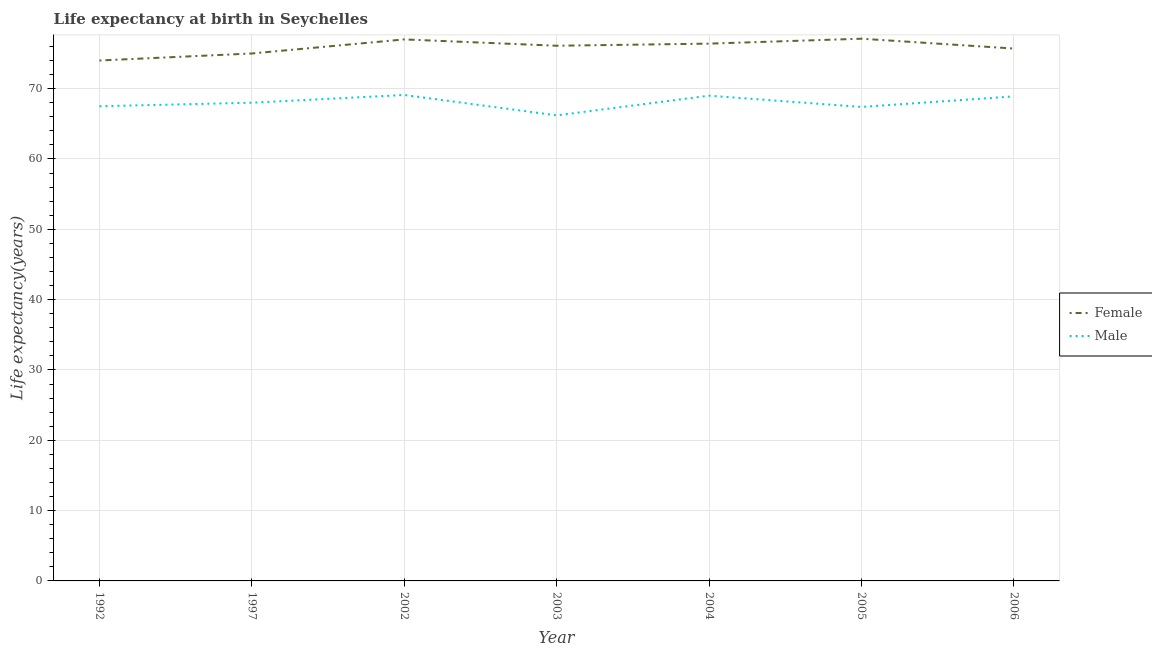Does the line corresponding to life expectancy(male) intersect with the line corresponding to life expectancy(female)?
Provide a succinct answer. No. Is the number of lines equal to the number of legend labels?
Offer a very short reply. Yes. Across all years, what is the maximum life expectancy(female)?
Give a very brief answer. 77.1. Across all years, what is the minimum life expectancy(male)?
Make the answer very short. 66.2. In which year was the life expectancy(female) maximum?
Make the answer very short. 2005. In which year was the life expectancy(male) minimum?
Your response must be concise. 2003. What is the total life expectancy(male) in the graph?
Provide a short and direct response. 476.1. What is the difference between the life expectancy(male) in 1992 and that in 2003?
Offer a very short reply. 1.3. What is the difference between the life expectancy(male) in 2003 and the life expectancy(female) in 2005?
Make the answer very short. -10.9. What is the average life expectancy(male) per year?
Your answer should be compact. 68.01. In the year 2006, what is the difference between the life expectancy(female) and life expectancy(male)?
Offer a terse response. 6.8. In how many years, is the life expectancy(female) greater than 30 years?
Keep it short and to the point. 7. What is the ratio of the life expectancy(female) in 2004 to that in 2006?
Offer a very short reply. 1.01. What is the difference between the highest and the second highest life expectancy(female)?
Make the answer very short. 0.1. What is the difference between the highest and the lowest life expectancy(female)?
Make the answer very short. 3.1. Is the sum of the life expectancy(female) in 1992 and 2005 greater than the maximum life expectancy(male) across all years?
Give a very brief answer. Yes. Is the life expectancy(female) strictly greater than the life expectancy(male) over the years?
Offer a terse response. Yes. How many lines are there?
Your answer should be compact. 2. How many years are there in the graph?
Offer a terse response. 7. What is the difference between two consecutive major ticks on the Y-axis?
Ensure brevity in your answer.  10. Does the graph contain grids?
Your response must be concise. Yes. What is the title of the graph?
Offer a very short reply. Life expectancy at birth in Seychelles. Does "Secondary education" appear as one of the legend labels in the graph?
Your answer should be very brief. No. What is the label or title of the Y-axis?
Make the answer very short. Life expectancy(years). What is the Life expectancy(years) of Female in 1992?
Offer a very short reply. 74. What is the Life expectancy(years) in Male in 1992?
Your answer should be very brief. 67.5. What is the Life expectancy(years) in Female in 1997?
Keep it short and to the point. 75. What is the Life expectancy(years) in Male in 1997?
Your answer should be very brief. 68. What is the Life expectancy(years) of Female in 2002?
Your answer should be very brief. 77. What is the Life expectancy(years) of Male in 2002?
Offer a very short reply. 69.1. What is the Life expectancy(years) of Female in 2003?
Provide a short and direct response. 76.1. What is the Life expectancy(years) of Male in 2003?
Offer a very short reply. 66.2. What is the Life expectancy(years) of Female in 2004?
Offer a terse response. 76.4. What is the Life expectancy(years) in Male in 2004?
Make the answer very short. 69. What is the Life expectancy(years) in Female in 2005?
Your answer should be very brief. 77.1. What is the Life expectancy(years) of Male in 2005?
Your answer should be very brief. 67.4. What is the Life expectancy(years) of Female in 2006?
Ensure brevity in your answer.  75.7. What is the Life expectancy(years) of Male in 2006?
Provide a succinct answer. 68.9. Across all years, what is the maximum Life expectancy(years) in Female?
Your answer should be very brief. 77.1. Across all years, what is the maximum Life expectancy(years) in Male?
Your response must be concise. 69.1. Across all years, what is the minimum Life expectancy(years) in Male?
Keep it short and to the point. 66.2. What is the total Life expectancy(years) of Female in the graph?
Offer a terse response. 531.3. What is the total Life expectancy(years) in Male in the graph?
Give a very brief answer. 476.1. What is the difference between the Life expectancy(years) in Female in 1992 and that in 2002?
Make the answer very short. -3. What is the difference between the Life expectancy(years) of Male in 1992 and that in 2003?
Ensure brevity in your answer.  1.3. What is the difference between the Life expectancy(years) of Female in 1992 and that in 2004?
Keep it short and to the point. -2.4. What is the difference between the Life expectancy(years) in Male in 1992 and that in 2004?
Make the answer very short. -1.5. What is the difference between the Life expectancy(years) of Female in 1992 and that in 2005?
Offer a terse response. -3.1. What is the difference between the Life expectancy(years) in Male in 1992 and that in 2005?
Give a very brief answer. 0.1. What is the difference between the Life expectancy(years) in Male in 1992 and that in 2006?
Your answer should be very brief. -1.4. What is the difference between the Life expectancy(years) of Female in 1997 and that in 2003?
Provide a short and direct response. -1.1. What is the difference between the Life expectancy(years) of Male in 1997 and that in 2004?
Provide a succinct answer. -1. What is the difference between the Life expectancy(years) in Female in 1997 and that in 2005?
Make the answer very short. -2.1. What is the difference between the Life expectancy(years) in Female in 1997 and that in 2006?
Give a very brief answer. -0.7. What is the difference between the Life expectancy(years) of Female in 2002 and that in 2003?
Provide a succinct answer. 0.9. What is the difference between the Life expectancy(years) of Male in 2002 and that in 2003?
Give a very brief answer. 2.9. What is the difference between the Life expectancy(years) of Female in 2002 and that in 2004?
Give a very brief answer. 0.6. What is the difference between the Life expectancy(years) in Male in 2002 and that in 2004?
Offer a terse response. 0.1. What is the difference between the Life expectancy(years) of Female in 2002 and that in 2005?
Make the answer very short. -0.1. What is the difference between the Life expectancy(years) of Male in 2002 and that in 2005?
Keep it short and to the point. 1.7. What is the difference between the Life expectancy(years) in Female in 2002 and that in 2006?
Ensure brevity in your answer.  1.3. What is the difference between the Life expectancy(years) in Male in 2002 and that in 2006?
Give a very brief answer. 0.2. What is the difference between the Life expectancy(years) of Female in 2003 and that in 2005?
Your answer should be very brief. -1. What is the difference between the Life expectancy(years) in Female in 2003 and that in 2006?
Provide a short and direct response. 0.4. What is the difference between the Life expectancy(years) in Female in 2004 and that in 2005?
Your answer should be very brief. -0.7. What is the difference between the Life expectancy(years) of Female in 2004 and that in 2006?
Provide a succinct answer. 0.7. What is the difference between the Life expectancy(years) of Female in 2005 and that in 2006?
Make the answer very short. 1.4. What is the difference between the Life expectancy(years) of Male in 2005 and that in 2006?
Keep it short and to the point. -1.5. What is the difference between the Life expectancy(years) in Female in 1992 and the Life expectancy(years) in Male in 1997?
Your answer should be compact. 6. What is the difference between the Life expectancy(years) in Female in 1992 and the Life expectancy(years) in Male in 2003?
Offer a very short reply. 7.8. What is the difference between the Life expectancy(years) of Female in 1992 and the Life expectancy(years) of Male in 2005?
Ensure brevity in your answer.  6.6. What is the difference between the Life expectancy(years) of Female in 1997 and the Life expectancy(years) of Male in 2004?
Give a very brief answer. 6. What is the difference between the Life expectancy(years) of Female in 1997 and the Life expectancy(years) of Male in 2005?
Your response must be concise. 7.6. What is the difference between the Life expectancy(years) of Female in 2002 and the Life expectancy(years) of Male in 2003?
Ensure brevity in your answer.  10.8. What is the difference between the Life expectancy(years) of Female in 2002 and the Life expectancy(years) of Male in 2004?
Keep it short and to the point. 8. What is the difference between the Life expectancy(years) in Female in 2002 and the Life expectancy(years) in Male in 2006?
Provide a short and direct response. 8.1. What is the difference between the Life expectancy(years) in Female in 2003 and the Life expectancy(years) in Male in 2004?
Your response must be concise. 7.1. What is the difference between the Life expectancy(years) in Female in 2005 and the Life expectancy(years) in Male in 2006?
Your answer should be very brief. 8.2. What is the average Life expectancy(years) of Female per year?
Give a very brief answer. 75.9. What is the average Life expectancy(years) of Male per year?
Offer a very short reply. 68.01. In the year 1992, what is the difference between the Life expectancy(years) in Female and Life expectancy(years) in Male?
Your answer should be very brief. 6.5. In the year 1997, what is the difference between the Life expectancy(years) in Female and Life expectancy(years) in Male?
Make the answer very short. 7. In the year 2004, what is the difference between the Life expectancy(years) in Female and Life expectancy(years) in Male?
Your answer should be very brief. 7.4. In the year 2005, what is the difference between the Life expectancy(years) in Female and Life expectancy(years) in Male?
Your response must be concise. 9.7. In the year 2006, what is the difference between the Life expectancy(years) in Female and Life expectancy(years) in Male?
Your answer should be compact. 6.8. What is the ratio of the Life expectancy(years) of Female in 1992 to that in 1997?
Your response must be concise. 0.99. What is the ratio of the Life expectancy(years) in Male in 1992 to that in 2002?
Provide a short and direct response. 0.98. What is the ratio of the Life expectancy(years) in Female in 1992 to that in 2003?
Give a very brief answer. 0.97. What is the ratio of the Life expectancy(years) of Male in 1992 to that in 2003?
Keep it short and to the point. 1.02. What is the ratio of the Life expectancy(years) in Female in 1992 to that in 2004?
Your answer should be very brief. 0.97. What is the ratio of the Life expectancy(years) of Male in 1992 to that in 2004?
Provide a succinct answer. 0.98. What is the ratio of the Life expectancy(years) in Female in 1992 to that in 2005?
Offer a terse response. 0.96. What is the ratio of the Life expectancy(years) of Female in 1992 to that in 2006?
Your response must be concise. 0.98. What is the ratio of the Life expectancy(years) of Male in 1992 to that in 2006?
Your answer should be compact. 0.98. What is the ratio of the Life expectancy(years) in Female in 1997 to that in 2002?
Offer a terse response. 0.97. What is the ratio of the Life expectancy(years) in Male in 1997 to that in 2002?
Your answer should be very brief. 0.98. What is the ratio of the Life expectancy(years) of Female in 1997 to that in 2003?
Your response must be concise. 0.99. What is the ratio of the Life expectancy(years) of Male in 1997 to that in 2003?
Keep it short and to the point. 1.03. What is the ratio of the Life expectancy(years) in Female in 1997 to that in 2004?
Offer a very short reply. 0.98. What is the ratio of the Life expectancy(years) of Male in 1997 to that in 2004?
Keep it short and to the point. 0.99. What is the ratio of the Life expectancy(years) in Female in 1997 to that in 2005?
Give a very brief answer. 0.97. What is the ratio of the Life expectancy(years) in Male in 1997 to that in 2005?
Provide a succinct answer. 1.01. What is the ratio of the Life expectancy(years) in Male in 1997 to that in 2006?
Make the answer very short. 0.99. What is the ratio of the Life expectancy(years) in Female in 2002 to that in 2003?
Your answer should be very brief. 1.01. What is the ratio of the Life expectancy(years) of Male in 2002 to that in 2003?
Provide a short and direct response. 1.04. What is the ratio of the Life expectancy(years) of Female in 2002 to that in 2004?
Provide a short and direct response. 1.01. What is the ratio of the Life expectancy(years) of Male in 2002 to that in 2004?
Ensure brevity in your answer.  1. What is the ratio of the Life expectancy(years) of Female in 2002 to that in 2005?
Provide a short and direct response. 1. What is the ratio of the Life expectancy(years) of Male in 2002 to that in 2005?
Your answer should be compact. 1.03. What is the ratio of the Life expectancy(years) of Female in 2002 to that in 2006?
Offer a very short reply. 1.02. What is the ratio of the Life expectancy(years) in Female in 2003 to that in 2004?
Your answer should be very brief. 1. What is the ratio of the Life expectancy(years) in Male in 2003 to that in 2004?
Keep it short and to the point. 0.96. What is the ratio of the Life expectancy(years) in Female in 2003 to that in 2005?
Make the answer very short. 0.99. What is the ratio of the Life expectancy(years) of Male in 2003 to that in 2005?
Give a very brief answer. 0.98. What is the ratio of the Life expectancy(years) in Male in 2003 to that in 2006?
Provide a short and direct response. 0.96. What is the ratio of the Life expectancy(years) in Female in 2004 to that in 2005?
Provide a short and direct response. 0.99. What is the ratio of the Life expectancy(years) of Male in 2004 to that in 2005?
Your answer should be compact. 1.02. What is the ratio of the Life expectancy(years) of Female in 2004 to that in 2006?
Ensure brevity in your answer.  1.01. What is the ratio of the Life expectancy(years) of Female in 2005 to that in 2006?
Keep it short and to the point. 1.02. What is the ratio of the Life expectancy(years) of Male in 2005 to that in 2006?
Your response must be concise. 0.98. What is the difference between the highest and the second highest Life expectancy(years) of Female?
Provide a succinct answer. 0.1. What is the difference between the highest and the lowest Life expectancy(years) of Female?
Make the answer very short. 3.1. What is the difference between the highest and the lowest Life expectancy(years) of Male?
Give a very brief answer. 2.9. 